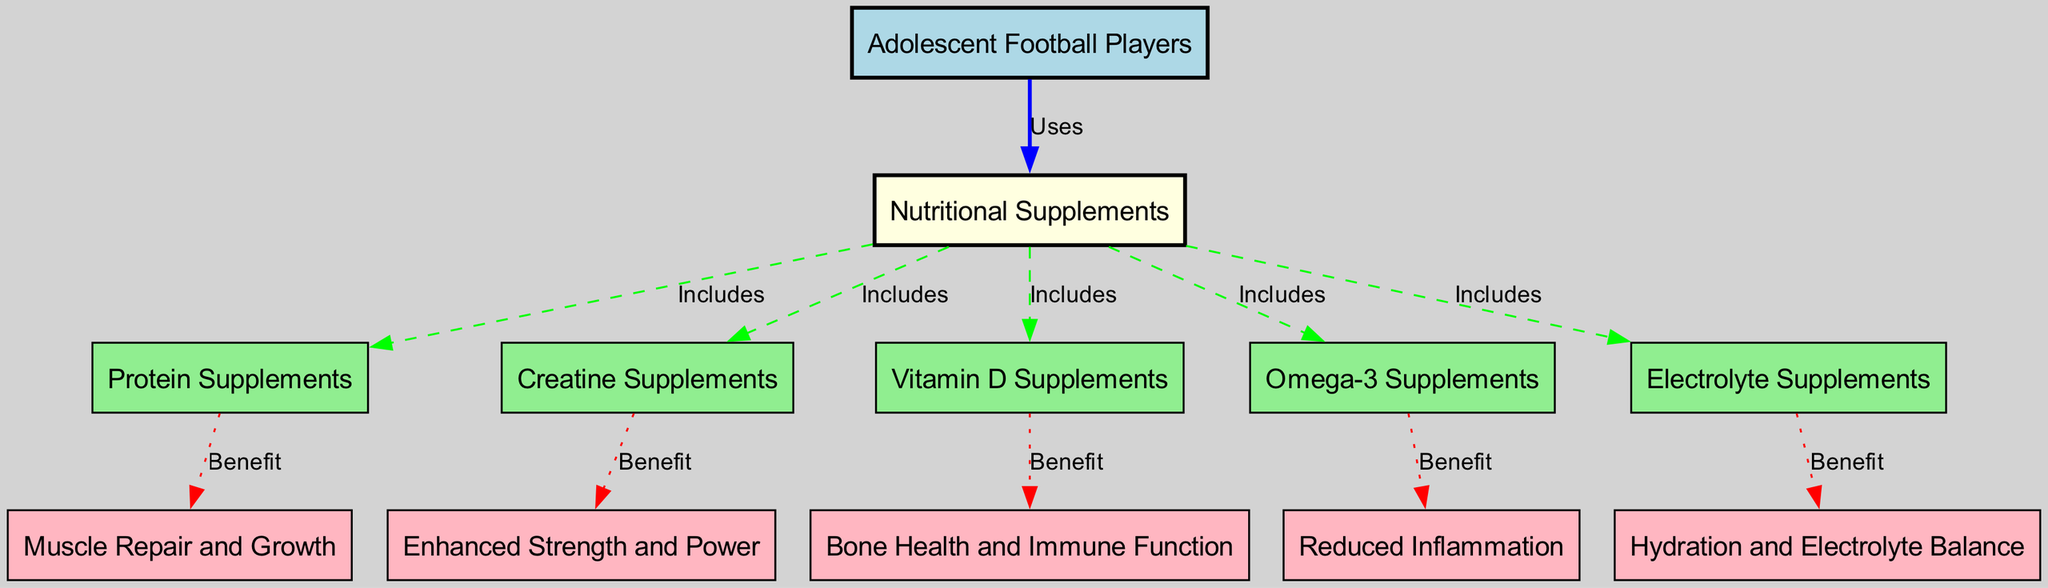What is the main subject of this diagram? The diagram focuses on the impact of nutritional supplements on adolescent football players, which is indicated at the top as "Adolescent Football Players."
Answer: Adolescent Football Players How many types of nutritional supplements are included in the diagram? The diagram shows five types of nutritional supplements: Protein, Creatine, Vitamin D, Omega-3, and Electrolyte Supplements.
Answer: Five What benefit is associated with Protein Supplements? The diagram connects Protein Supplements to the benefit of Muscle Repair and Growth, which is shown directly following Protein Supplements.
Answer: Muscle Repair and Growth Which supplement is linked to Bone Health and Immune Function? The diagram shows Vitamin D Supplements leading to the benefit of Bone Health and Immune Function, making the association clear.
Answer: Vitamin D Supplements What relationship exists between Nutritional Supplements and Electrolyte Supplements? The diagram indicates that Nutritional Supplements includes Electrolyte Supplements, which is a direct connection shown between these two nodes.
Answer: Includes How many benefits are listed for the different nutritional supplements? The diagram features a total of five benefits corresponding to each of the five types of nutritional supplements.
Answer: Five Which supplement aims to reduce inflammation? The diagram specifically links Omega-3 Supplements to the benefit of Reduced Inflammation, indicating this clear connection.
Answer: Omega-3 Supplements Which type of supplements is associated with enhanced strength and power? The diagram illustrates that Creatine Supplements provide the benefit of Enhanced Strength and Power, depicting this relation.
Answer: Creatine Supplements What are the main uses of nutritional supplements according to the diagram? The diagram states that Nutritional Supplements are used by Adolescent Football Players, indicating the primary application.
Answer: Uses 